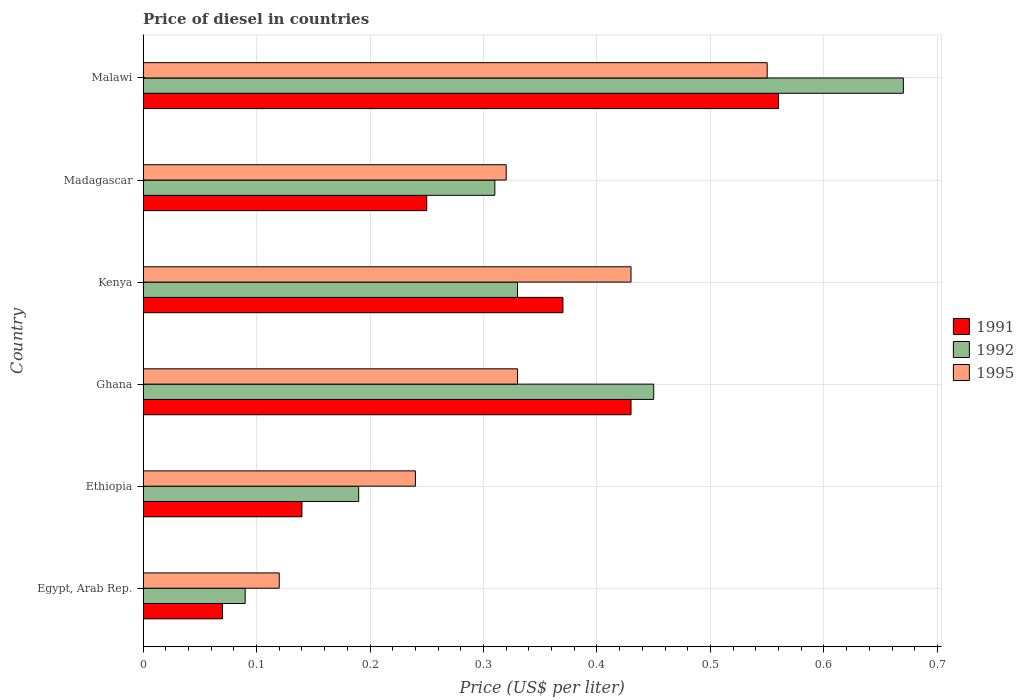How many groups of bars are there?
Give a very brief answer. 6. How many bars are there on the 2nd tick from the top?
Keep it short and to the point. 3. How many bars are there on the 1st tick from the bottom?
Offer a terse response. 3. What is the label of the 3rd group of bars from the top?
Your answer should be very brief. Kenya. In how many cases, is the number of bars for a given country not equal to the number of legend labels?
Offer a terse response. 0. What is the price of diesel in 1991 in Ethiopia?
Keep it short and to the point. 0.14. Across all countries, what is the maximum price of diesel in 1995?
Your response must be concise. 0.55. Across all countries, what is the minimum price of diesel in 1991?
Provide a short and direct response. 0.07. In which country was the price of diesel in 1995 maximum?
Ensure brevity in your answer.  Malawi. In which country was the price of diesel in 1995 minimum?
Ensure brevity in your answer.  Egypt, Arab Rep. What is the total price of diesel in 1992 in the graph?
Provide a short and direct response. 2.04. What is the difference between the price of diesel in 1992 in Ethiopia and that in Malawi?
Keep it short and to the point. -0.48. What is the difference between the price of diesel in 1991 in Ghana and the price of diesel in 1995 in Madagascar?
Your response must be concise. 0.11. What is the average price of diesel in 1991 per country?
Your answer should be compact. 0.3. What is the difference between the price of diesel in 1991 and price of diesel in 1992 in Egypt, Arab Rep.?
Ensure brevity in your answer.  -0.02. In how many countries, is the price of diesel in 1991 greater than 0.08 US$?
Offer a very short reply. 5. What is the ratio of the price of diesel in 1991 in Ghana to that in Kenya?
Your answer should be compact. 1.16. Is the price of diesel in 1991 in Egypt, Arab Rep. less than that in Kenya?
Your answer should be very brief. Yes. What is the difference between the highest and the second highest price of diesel in 1995?
Provide a succinct answer. 0.12. What is the difference between the highest and the lowest price of diesel in 1992?
Keep it short and to the point. 0.58. In how many countries, is the price of diesel in 1992 greater than the average price of diesel in 1992 taken over all countries?
Your response must be concise. 2. Is the sum of the price of diesel in 1995 in Madagascar and Malawi greater than the maximum price of diesel in 1992 across all countries?
Make the answer very short. Yes. What does the 2nd bar from the bottom in Ghana represents?
Your answer should be compact. 1992. Are all the bars in the graph horizontal?
Ensure brevity in your answer.  Yes. What is the difference between two consecutive major ticks on the X-axis?
Make the answer very short. 0.1. Are the values on the major ticks of X-axis written in scientific E-notation?
Keep it short and to the point. No. How many legend labels are there?
Give a very brief answer. 3. How are the legend labels stacked?
Make the answer very short. Vertical. What is the title of the graph?
Provide a short and direct response. Price of diesel in countries. Does "1975" appear as one of the legend labels in the graph?
Ensure brevity in your answer.  No. What is the label or title of the X-axis?
Give a very brief answer. Price (US$ per liter). What is the Price (US$ per liter) in 1991 in Egypt, Arab Rep.?
Offer a very short reply. 0.07. What is the Price (US$ per liter) in 1992 in Egypt, Arab Rep.?
Offer a terse response. 0.09. What is the Price (US$ per liter) of 1995 in Egypt, Arab Rep.?
Make the answer very short. 0.12. What is the Price (US$ per liter) in 1991 in Ethiopia?
Your response must be concise. 0.14. What is the Price (US$ per liter) of 1992 in Ethiopia?
Make the answer very short. 0.19. What is the Price (US$ per liter) in 1995 in Ethiopia?
Provide a succinct answer. 0.24. What is the Price (US$ per liter) in 1991 in Ghana?
Offer a terse response. 0.43. What is the Price (US$ per liter) in 1992 in Ghana?
Keep it short and to the point. 0.45. What is the Price (US$ per liter) of 1995 in Ghana?
Provide a short and direct response. 0.33. What is the Price (US$ per liter) in 1991 in Kenya?
Give a very brief answer. 0.37. What is the Price (US$ per liter) of 1992 in Kenya?
Give a very brief answer. 0.33. What is the Price (US$ per liter) of 1995 in Kenya?
Ensure brevity in your answer.  0.43. What is the Price (US$ per liter) of 1992 in Madagascar?
Offer a very short reply. 0.31. What is the Price (US$ per liter) of 1995 in Madagascar?
Give a very brief answer. 0.32. What is the Price (US$ per liter) of 1991 in Malawi?
Your answer should be compact. 0.56. What is the Price (US$ per liter) in 1992 in Malawi?
Provide a short and direct response. 0.67. What is the Price (US$ per liter) of 1995 in Malawi?
Ensure brevity in your answer.  0.55. Across all countries, what is the maximum Price (US$ per liter) of 1991?
Give a very brief answer. 0.56. Across all countries, what is the maximum Price (US$ per liter) in 1992?
Offer a terse response. 0.67. Across all countries, what is the maximum Price (US$ per liter) of 1995?
Your answer should be very brief. 0.55. Across all countries, what is the minimum Price (US$ per liter) of 1991?
Provide a succinct answer. 0.07. Across all countries, what is the minimum Price (US$ per liter) of 1992?
Offer a very short reply. 0.09. Across all countries, what is the minimum Price (US$ per liter) in 1995?
Offer a very short reply. 0.12. What is the total Price (US$ per liter) in 1991 in the graph?
Ensure brevity in your answer.  1.82. What is the total Price (US$ per liter) in 1992 in the graph?
Give a very brief answer. 2.04. What is the total Price (US$ per liter) in 1995 in the graph?
Make the answer very short. 1.99. What is the difference between the Price (US$ per liter) in 1991 in Egypt, Arab Rep. and that in Ethiopia?
Provide a short and direct response. -0.07. What is the difference between the Price (US$ per liter) of 1995 in Egypt, Arab Rep. and that in Ethiopia?
Give a very brief answer. -0.12. What is the difference between the Price (US$ per liter) of 1991 in Egypt, Arab Rep. and that in Ghana?
Provide a succinct answer. -0.36. What is the difference between the Price (US$ per liter) in 1992 in Egypt, Arab Rep. and that in Ghana?
Offer a very short reply. -0.36. What is the difference between the Price (US$ per liter) in 1995 in Egypt, Arab Rep. and that in Ghana?
Your response must be concise. -0.21. What is the difference between the Price (US$ per liter) of 1991 in Egypt, Arab Rep. and that in Kenya?
Make the answer very short. -0.3. What is the difference between the Price (US$ per liter) of 1992 in Egypt, Arab Rep. and that in Kenya?
Your answer should be compact. -0.24. What is the difference between the Price (US$ per liter) in 1995 in Egypt, Arab Rep. and that in Kenya?
Offer a very short reply. -0.31. What is the difference between the Price (US$ per liter) in 1991 in Egypt, Arab Rep. and that in Madagascar?
Provide a succinct answer. -0.18. What is the difference between the Price (US$ per liter) in 1992 in Egypt, Arab Rep. and that in Madagascar?
Your answer should be very brief. -0.22. What is the difference between the Price (US$ per liter) of 1995 in Egypt, Arab Rep. and that in Madagascar?
Ensure brevity in your answer.  -0.2. What is the difference between the Price (US$ per liter) in 1991 in Egypt, Arab Rep. and that in Malawi?
Your answer should be compact. -0.49. What is the difference between the Price (US$ per liter) of 1992 in Egypt, Arab Rep. and that in Malawi?
Make the answer very short. -0.58. What is the difference between the Price (US$ per liter) in 1995 in Egypt, Arab Rep. and that in Malawi?
Offer a very short reply. -0.43. What is the difference between the Price (US$ per liter) of 1991 in Ethiopia and that in Ghana?
Make the answer very short. -0.29. What is the difference between the Price (US$ per liter) in 1992 in Ethiopia and that in Ghana?
Make the answer very short. -0.26. What is the difference between the Price (US$ per liter) in 1995 in Ethiopia and that in Ghana?
Your answer should be very brief. -0.09. What is the difference between the Price (US$ per liter) in 1991 in Ethiopia and that in Kenya?
Keep it short and to the point. -0.23. What is the difference between the Price (US$ per liter) in 1992 in Ethiopia and that in Kenya?
Keep it short and to the point. -0.14. What is the difference between the Price (US$ per liter) of 1995 in Ethiopia and that in Kenya?
Your response must be concise. -0.19. What is the difference between the Price (US$ per liter) of 1991 in Ethiopia and that in Madagascar?
Make the answer very short. -0.11. What is the difference between the Price (US$ per liter) of 1992 in Ethiopia and that in Madagascar?
Make the answer very short. -0.12. What is the difference between the Price (US$ per liter) of 1995 in Ethiopia and that in Madagascar?
Offer a terse response. -0.08. What is the difference between the Price (US$ per liter) in 1991 in Ethiopia and that in Malawi?
Your response must be concise. -0.42. What is the difference between the Price (US$ per liter) in 1992 in Ethiopia and that in Malawi?
Your response must be concise. -0.48. What is the difference between the Price (US$ per liter) of 1995 in Ethiopia and that in Malawi?
Offer a very short reply. -0.31. What is the difference between the Price (US$ per liter) in 1991 in Ghana and that in Kenya?
Provide a short and direct response. 0.06. What is the difference between the Price (US$ per liter) in 1992 in Ghana and that in Kenya?
Your answer should be compact. 0.12. What is the difference between the Price (US$ per liter) of 1995 in Ghana and that in Kenya?
Your answer should be very brief. -0.1. What is the difference between the Price (US$ per liter) in 1991 in Ghana and that in Madagascar?
Your response must be concise. 0.18. What is the difference between the Price (US$ per liter) in 1992 in Ghana and that in Madagascar?
Your answer should be very brief. 0.14. What is the difference between the Price (US$ per liter) of 1991 in Ghana and that in Malawi?
Offer a very short reply. -0.13. What is the difference between the Price (US$ per liter) in 1992 in Ghana and that in Malawi?
Your answer should be compact. -0.22. What is the difference between the Price (US$ per liter) in 1995 in Ghana and that in Malawi?
Give a very brief answer. -0.22. What is the difference between the Price (US$ per liter) in 1991 in Kenya and that in Madagascar?
Your answer should be compact. 0.12. What is the difference between the Price (US$ per liter) in 1995 in Kenya and that in Madagascar?
Offer a very short reply. 0.11. What is the difference between the Price (US$ per liter) of 1991 in Kenya and that in Malawi?
Keep it short and to the point. -0.19. What is the difference between the Price (US$ per liter) in 1992 in Kenya and that in Malawi?
Ensure brevity in your answer.  -0.34. What is the difference between the Price (US$ per liter) in 1995 in Kenya and that in Malawi?
Ensure brevity in your answer.  -0.12. What is the difference between the Price (US$ per liter) in 1991 in Madagascar and that in Malawi?
Make the answer very short. -0.31. What is the difference between the Price (US$ per liter) in 1992 in Madagascar and that in Malawi?
Your answer should be compact. -0.36. What is the difference between the Price (US$ per liter) in 1995 in Madagascar and that in Malawi?
Your answer should be compact. -0.23. What is the difference between the Price (US$ per liter) of 1991 in Egypt, Arab Rep. and the Price (US$ per liter) of 1992 in Ethiopia?
Offer a terse response. -0.12. What is the difference between the Price (US$ per liter) of 1991 in Egypt, Arab Rep. and the Price (US$ per liter) of 1995 in Ethiopia?
Offer a terse response. -0.17. What is the difference between the Price (US$ per liter) in 1991 in Egypt, Arab Rep. and the Price (US$ per liter) in 1992 in Ghana?
Offer a very short reply. -0.38. What is the difference between the Price (US$ per liter) of 1991 in Egypt, Arab Rep. and the Price (US$ per liter) of 1995 in Ghana?
Give a very brief answer. -0.26. What is the difference between the Price (US$ per liter) in 1992 in Egypt, Arab Rep. and the Price (US$ per liter) in 1995 in Ghana?
Offer a very short reply. -0.24. What is the difference between the Price (US$ per liter) in 1991 in Egypt, Arab Rep. and the Price (US$ per liter) in 1992 in Kenya?
Your answer should be compact. -0.26. What is the difference between the Price (US$ per liter) of 1991 in Egypt, Arab Rep. and the Price (US$ per liter) of 1995 in Kenya?
Ensure brevity in your answer.  -0.36. What is the difference between the Price (US$ per liter) of 1992 in Egypt, Arab Rep. and the Price (US$ per liter) of 1995 in Kenya?
Your answer should be compact. -0.34. What is the difference between the Price (US$ per liter) in 1991 in Egypt, Arab Rep. and the Price (US$ per liter) in 1992 in Madagascar?
Your answer should be compact. -0.24. What is the difference between the Price (US$ per liter) of 1992 in Egypt, Arab Rep. and the Price (US$ per liter) of 1995 in Madagascar?
Your response must be concise. -0.23. What is the difference between the Price (US$ per liter) in 1991 in Egypt, Arab Rep. and the Price (US$ per liter) in 1995 in Malawi?
Provide a succinct answer. -0.48. What is the difference between the Price (US$ per liter) of 1992 in Egypt, Arab Rep. and the Price (US$ per liter) of 1995 in Malawi?
Offer a terse response. -0.46. What is the difference between the Price (US$ per liter) in 1991 in Ethiopia and the Price (US$ per liter) in 1992 in Ghana?
Your answer should be very brief. -0.31. What is the difference between the Price (US$ per liter) of 1991 in Ethiopia and the Price (US$ per liter) of 1995 in Ghana?
Provide a succinct answer. -0.19. What is the difference between the Price (US$ per liter) of 1992 in Ethiopia and the Price (US$ per liter) of 1995 in Ghana?
Your response must be concise. -0.14. What is the difference between the Price (US$ per liter) of 1991 in Ethiopia and the Price (US$ per liter) of 1992 in Kenya?
Give a very brief answer. -0.19. What is the difference between the Price (US$ per liter) in 1991 in Ethiopia and the Price (US$ per liter) in 1995 in Kenya?
Provide a short and direct response. -0.29. What is the difference between the Price (US$ per liter) of 1992 in Ethiopia and the Price (US$ per liter) of 1995 in Kenya?
Give a very brief answer. -0.24. What is the difference between the Price (US$ per liter) of 1991 in Ethiopia and the Price (US$ per liter) of 1992 in Madagascar?
Give a very brief answer. -0.17. What is the difference between the Price (US$ per liter) in 1991 in Ethiopia and the Price (US$ per liter) in 1995 in Madagascar?
Offer a very short reply. -0.18. What is the difference between the Price (US$ per liter) in 1992 in Ethiopia and the Price (US$ per liter) in 1995 in Madagascar?
Your answer should be very brief. -0.13. What is the difference between the Price (US$ per liter) of 1991 in Ethiopia and the Price (US$ per liter) of 1992 in Malawi?
Make the answer very short. -0.53. What is the difference between the Price (US$ per liter) in 1991 in Ethiopia and the Price (US$ per liter) in 1995 in Malawi?
Ensure brevity in your answer.  -0.41. What is the difference between the Price (US$ per liter) of 1992 in Ethiopia and the Price (US$ per liter) of 1995 in Malawi?
Make the answer very short. -0.36. What is the difference between the Price (US$ per liter) in 1992 in Ghana and the Price (US$ per liter) in 1995 in Kenya?
Provide a succinct answer. 0.02. What is the difference between the Price (US$ per liter) in 1991 in Ghana and the Price (US$ per liter) in 1992 in Madagascar?
Your answer should be compact. 0.12. What is the difference between the Price (US$ per liter) of 1991 in Ghana and the Price (US$ per liter) of 1995 in Madagascar?
Offer a terse response. 0.11. What is the difference between the Price (US$ per liter) in 1992 in Ghana and the Price (US$ per liter) in 1995 in Madagascar?
Make the answer very short. 0.13. What is the difference between the Price (US$ per liter) of 1991 in Ghana and the Price (US$ per liter) of 1992 in Malawi?
Offer a terse response. -0.24. What is the difference between the Price (US$ per liter) in 1991 in Ghana and the Price (US$ per liter) in 1995 in Malawi?
Offer a very short reply. -0.12. What is the difference between the Price (US$ per liter) of 1991 in Kenya and the Price (US$ per liter) of 1992 in Madagascar?
Provide a succinct answer. 0.06. What is the difference between the Price (US$ per liter) of 1991 in Kenya and the Price (US$ per liter) of 1995 in Madagascar?
Your response must be concise. 0.05. What is the difference between the Price (US$ per liter) of 1991 in Kenya and the Price (US$ per liter) of 1995 in Malawi?
Provide a succinct answer. -0.18. What is the difference between the Price (US$ per liter) of 1992 in Kenya and the Price (US$ per liter) of 1995 in Malawi?
Provide a succinct answer. -0.22. What is the difference between the Price (US$ per liter) of 1991 in Madagascar and the Price (US$ per liter) of 1992 in Malawi?
Make the answer very short. -0.42. What is the difference between the Price (US$ per liter) in 1992 in Madagascar and the Price (US$ per liter) in 1995 in Malawi?
Your response must be concise. -0.24. What is the average Price (US$ per liter) in 1991 per country?
Give a very brief answer. 0.3. What is the average Price (US$ per liter) in 1992 per country?
Offer a terse response. 0.34. What is the average Price (US$ per liter) of 1995 per country?
Provide a succinct answer. 0.33. What is the difference between the Price (US$ per liter) of 1991 and Price (US$ per liter) of 1992 in Egypt, Arab Rep.?
Give a very brief answer. -0.02. What is the difference between the Price (US$ per liter) in 1991 and Price (US$ per liter) in 1995 in Egypt, Arab Rep.?
Keep it short and to the point. -0.05. What is the difference between the Price (US$ per liter) of 1992 and Price (US$ per liter) of 1995 in Egypt, Arab Rep.?
Keep it short and to the point. -0.03. What is the difference between the Price (US$ per liter) of 1991 and Price (US$ per liter) of 1995 in Ethiopia?
Give a very brief answer. -0.1. What is the difference between the Price (US$ per liter) of 1992 and Price (US$ per liter) of 1995 in Ethiopia?
Your response must be concise. -0.05. What is the difference between the Price (US$ per liter) in 1991 and Price (US$ per liter) in 1992 in Ghana?
Your answer should be very brief. -0.02. What is the difference between the Price (US$ per liter) of 1991 and Price (US$ per liter) of 1995 in Ghana?
Your answer should be very brief. 0.1. What is the difference between the Price (US$ per liter) of 1992 and Price (US$ per liter) of 1995 in Ghana?
Make the answer very short. 0.12. What is the difference between the Price (US$ per liter) of 1991 and Price (US$ per liter) of 1995 in Kenya?
Provide a short and direct response. -0.06. What is the difference between the Price (US$ per liter) in 1991 and Price (US$ per liter) in 1992 in Madagascar?
Ensure brevity in your answer.  -0.06. What is the difference between the Price (US$ per liter) in 1991 and Price (US$ per liter) in 1995 in Madagascar?
Keep it short and to the point. -0.07. What is the difference between the Price (US$ per liter) in 1992 and Price (US$ per liter) in 1995 in Madagascar?
Keep it short and to the point. -0.01. What is the difference between the Price (US$ per liter) of 1991 and Price (US$ per liter) of 1992 in Malawi?
Your response must be concise. -0.11. What is the difference between the Price (US$ per liter) of 1991 and Price (US$ per liter) of 1995 in Malawi?
Give a very brief answer. 0.01. What is the difference between the Price (US$ per liter) of 1992 and Price (US$ per liter) of 1995 in Malawi?
Provide a short and direct response. 0.12. What is the ratio of the Price (US$ per liter) of 1991 in Egypt, Arab Rep. to that in Ethiopia?
Make the answer very short. 0.5. What is the ratio of the Price (US$ per liter) in 1992 in Egypt, Arab Rep. to that in Ethiopia?
Your answer should be compact. 0.47. What is the ratio of the Price (US$ per liter) of 1991 in Egypt, Arab Rep. to that in Ghana?
Your response must be concise. 0.16. What is the ratio of the Price (US$ per liter) of 1992 in Egypt, Arab Rep. to that in Ghana?
Provide a succinct answer. 0.2. What is the ratio of the Price (US$ per liter) in 1995 in Egypt, Arab Rep. to that in Ghana?
Offer a very short reply. 0.36. What is the ratio of the Price (US$ per liter) in 1991 in Egypt, Arab Rep. to that in Kenya?
Give a very brief answer. 0.19. What is the ratio of the Price (US$ per liter) of 1992 in Egypt, Arab Rep. to that in Kenya?
Offer a very short reply. 0.27. What is the ratio of the Price (US$ per liter) in 1995 in Egypt, Arab Rep. to that in Kenya?
Keep it short and to the point. 0.28. What is the ratio of the Price (US$ per liter) in 1991 in Egypt, Arab Rep. to that in Madagascar?
Your answer should be very brief. 0.28. What is the ratio of the Price (US$ per liter) in 1992 in Egypt, Arab Rep. to that in Madagascar?
Make the answer very short. 0.29. What is the ratio of the Price (US$ per liter) in 1995 in Egypt, Arab Rep. to that in Madagascar?
Your response must be concise. 0.38. What is the ratio of the Price (US$ per liter) of 1991 in Egypt, Arab Rep. to that in Malawi?
Your answer should be compact. 0.12. What is the ratio of the Price (US$ per liter) of 1992 in Egypt, Arab Rep. to that in Malawi?
Offer a very short reply. 0.13. What is the ratio of the Price (US$ per liter) in 1995 in Egypt, Arab Rep. to that in Malawi?
Your answer should be compact. 0.22. What is the ratio of the Price (US$ per liter) of 1991 in Ethiopia to that in Ghana?
Offer a terse response. 0.33. What is the ratio of the Price (US$ per liter) of 1992 in Ethiopia to that in Ghana?
Offer a terse response. 0.42. What is the ratio of the Price (US$ per liter) of 1995 in Ethiopia to that in Ghana?
Offer a very short reply. 0.73. What is the ratio of the Price (US$ per liter) in 1991 in Ethiopia to that in Kenya?
Your answer should be very brief. 0.38. What is the ratio of the Price (US$ per liter) in 1992 in Ethiopia to that in Kenya?
Keep it short and to the point. 0.58. What is the ratio of the Price (US$ per liter) of 1995 in Ethiopia to that in Kenya?
Keep it short and to the point. 0.56. What is the ratio of the Price (US$ per liter) of 1991 in Ethiopia to that in Madagascar?
Ensure brevity in your answer.  0.56. What is the ratio of the Price (US$ per liter) of 1992 in Ethiopia to that in Madagascar?
Provide a succinct answer. 0.61. What is the ratio of the Price (US$ per liter) of 1995 in Ethiopia to that in Madagascar?
Make the answer very short. 0.75. What is the ratio of the Price (US$ per liter) in 1991 in Ethiopia to that in Malawi?
Offer a very short reply. 0.25. What is the ratio of the Price (US$ per liter) in 1992 in Ethiopia to that in Malawi?
Give a very brief answer. 0.28. What is the ratio of the Price (US$ per liter) in 1995 in Ethiopia to that in Malawi?
Your response must be concise. 0.44. What is the ratio of the Price (US$ per liter) in 1991 in Ghana to that in Kenya?
Your answer should be very brief. 1.16. What is the ratio of the Price (US$ per liter) of 1992 in Ghana to that in Kenya?
Give a very brief answer. 1.36. What is the ratio of the Price (US$ per liter) in 1995 in Ghana to that in Kenya?
Ensure brevity in your answer.  0.77. What is the ratio of the Price (US$ per liter) of 1991 in Ghana to that in Madagascar?
Provide a short and direct response. 1.72. What is the ratio of the Price (US$ per liter) of 1992 in Ghana to that in Madagascar?
Offer a terse response. 1.45. What is the ratio of the Price (US$ per liter) in 1995 in Ghana to that in Madagascar?
Offer a very short reply. 1.03. What is the ratio of the Price (US$ per liter) in 1991 in Ghana to that in Malawi?
Keep it short and to the point. 0.77. What is the ratio of the Price (US$ per liter) in 1992 in Ghana to that in Malawi?
Provide a short and direct response. 0.67. What is the ratio of the Price (US$ per liter) of 1995 in Ghana to that in Malawi?
Ensure brevity in your answer.  0.6. What is the ratio of the Price (US$ per liter) of 1991 in Kenya to that in Madagascar?
Your answer should be compact. 1.48. What is the ratio of the Price (US$ per liter) of 1992 in Kenya to that in Madagascar?
Offer a very short reply. 1.06. What is the ratio of the Price (US$ per liter) of 1995 in Kenya to that in Madagascar?
Your response must be concise. 1.34. What is the ratio of the Price (US$ per liter) of 1991 in Kenya to that in Malawi?
Give a very brief answer. 0.66. What is the ratio of the Price (US$ per liter) in 1992 in Kenya to that in Malawi?
Your answer should be compact. 0.49. What is the ratio of the Price (US$ per liter) in 1995 in Kenya to that in Malawi?
Make the answer very short. 0.78. What is the ratio of the Price (US$ per liter) in 1991 in Madagascar to that in Malawi?
Offer a terse response. 0.45. What is the ratio of the Price (US$ per liter) of 1992 in Madagascar to that in Malawi?
Ensure brevity in your answer.  0.46. What is the ratio of the Price (US$ per liter) of 1995 in Madagascar to that in Malawi?
Your response must be concise. 0.58. What is the difference between the highest and the second highest Price (US$ per liter) of 1991?
Keep it short and to the point. 0.13. What is the difference between the highest and the second highest Price (US$ per liter) of 1992?
Give a very brief answer. 0.22. What is the difference between the highest and the second highest Price (US$ per liter) in 1995?
Keep it short and to the point. 0.12. What is the difference between the highest and the lowest Price (US$ per liter) in 1991?
Provide a short and direct response. 0.49. What is the difference between the highest and the lowest Price (US$ per liter) of 1992?
Give a very brief answer. 0.58. What is the difference between the highest and the lowest Price (US$ per liter) in 1995?
Offer a terse response. 0.43. 